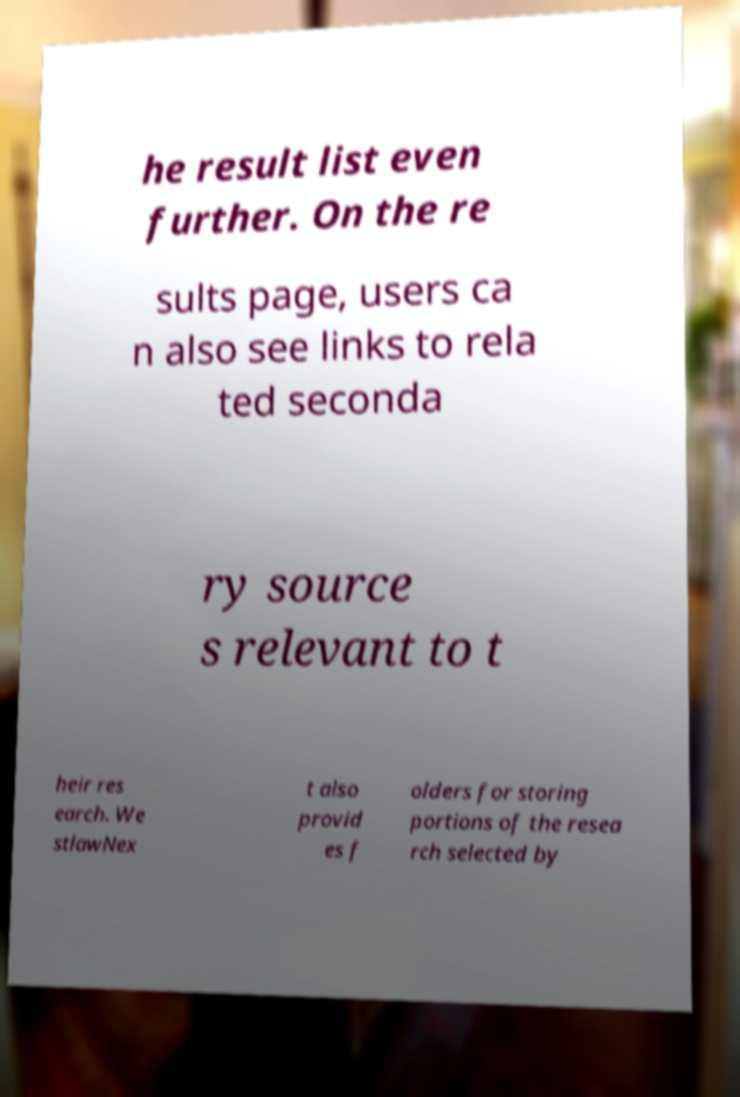Please read and relay the text visible in this image. What does it say? he result list even further. On the re sults page, users ca n also see links to rela ted seconda ry source s relevant to t heir res earch. We stlawNex t also provid es f olders for storing portions of the resea rch selected by 